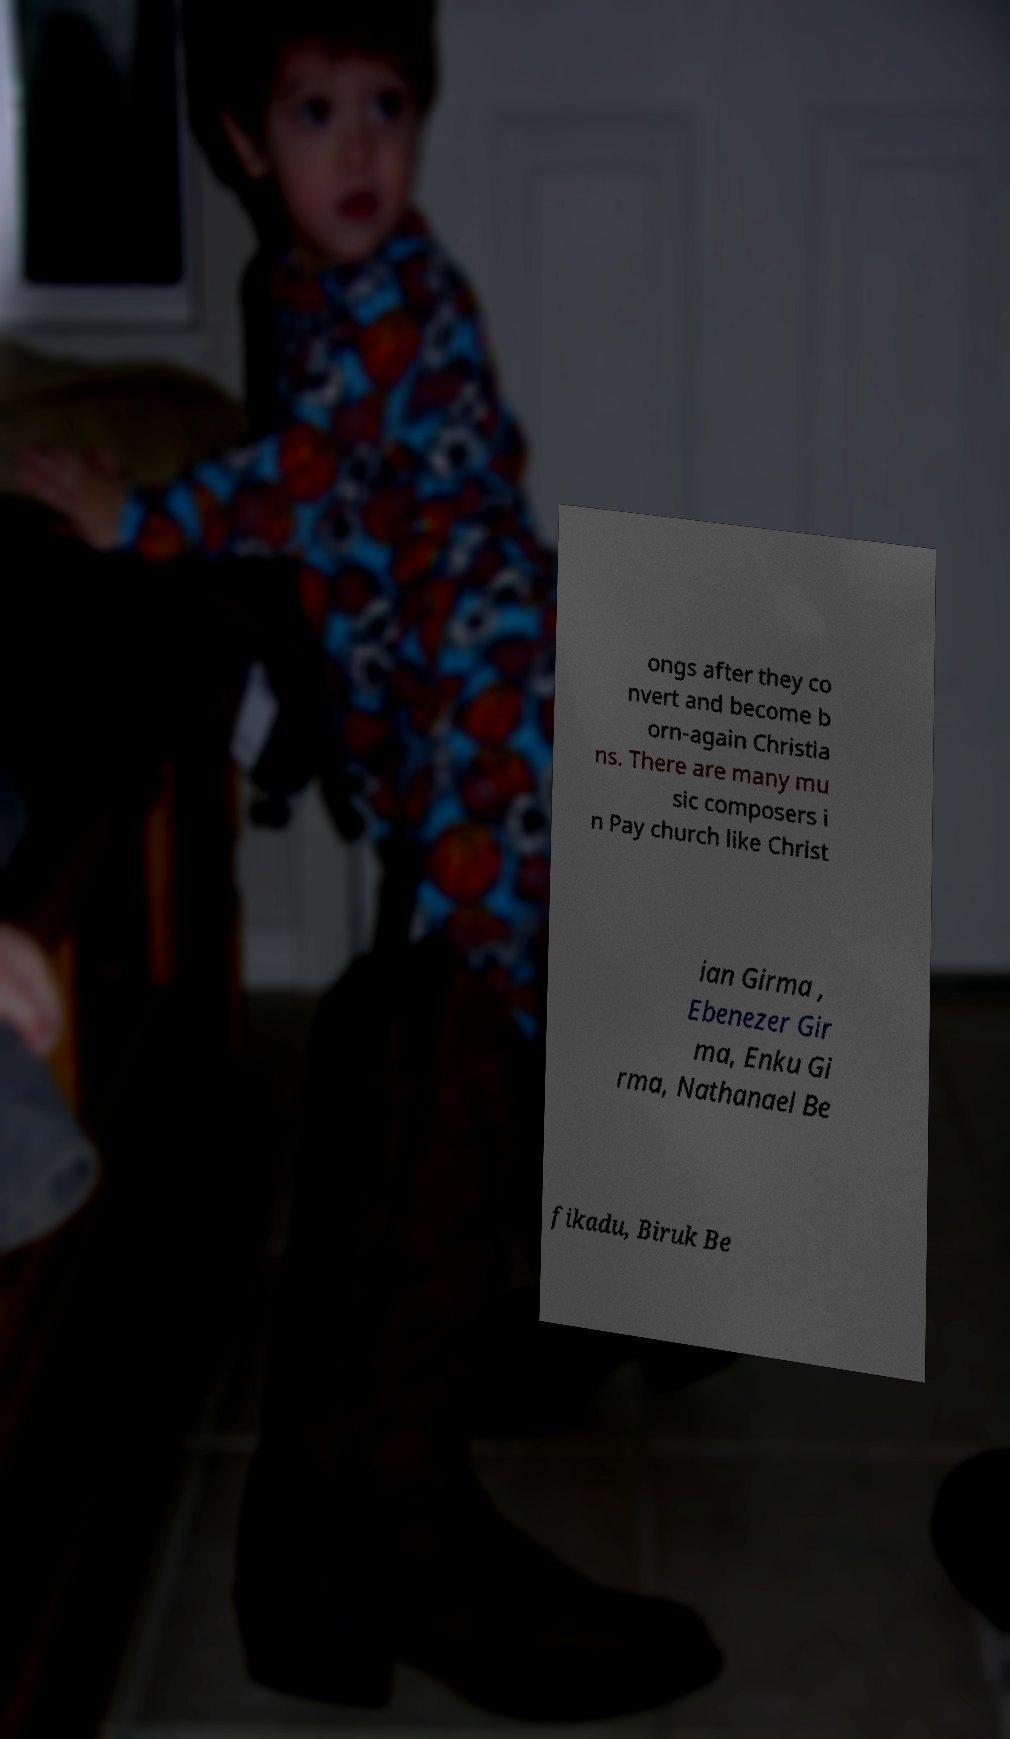I need the written content from this picture converted into text. Can you do that? ongs after they co nvert and become b orn-again Christia ns. There are many mu sic composers i n Pay church like Christ ian Girma , Ebenezer Gir ma, Enku Gi rma, Nathanael Be fikadu, Biruk Be 